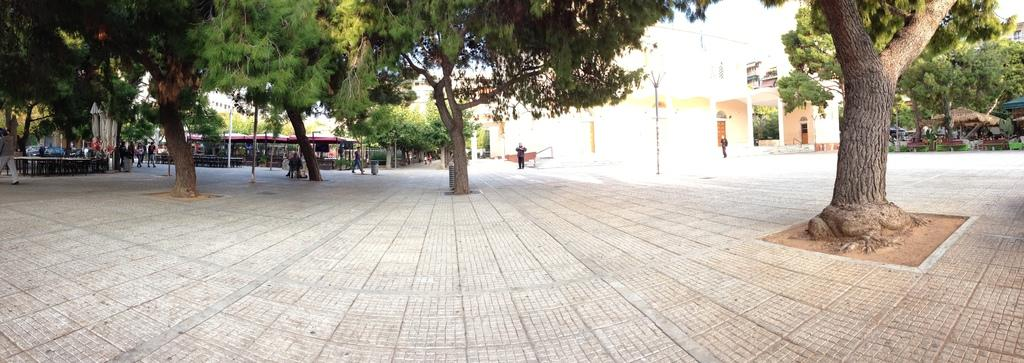Who or what can be seen in the image? There are people in the image. What type of structures are visible in the image? There are buildings, a tent, and a shed in the image. What natural elements can be seen in the image? There are trees in the image. What man-made objects are present in the image? There are poles, windows, and objects on the ground in the image. What type of lighting is present in the image? There is a light in the image. What is the name of the daughter of the person standing near the tent in the image? There is no mention of a daughter or a person standing near the tent in the image. How many people are in the group that is washing the windows in the image? There is no group washing windows in the image; there are only people and windows present. 